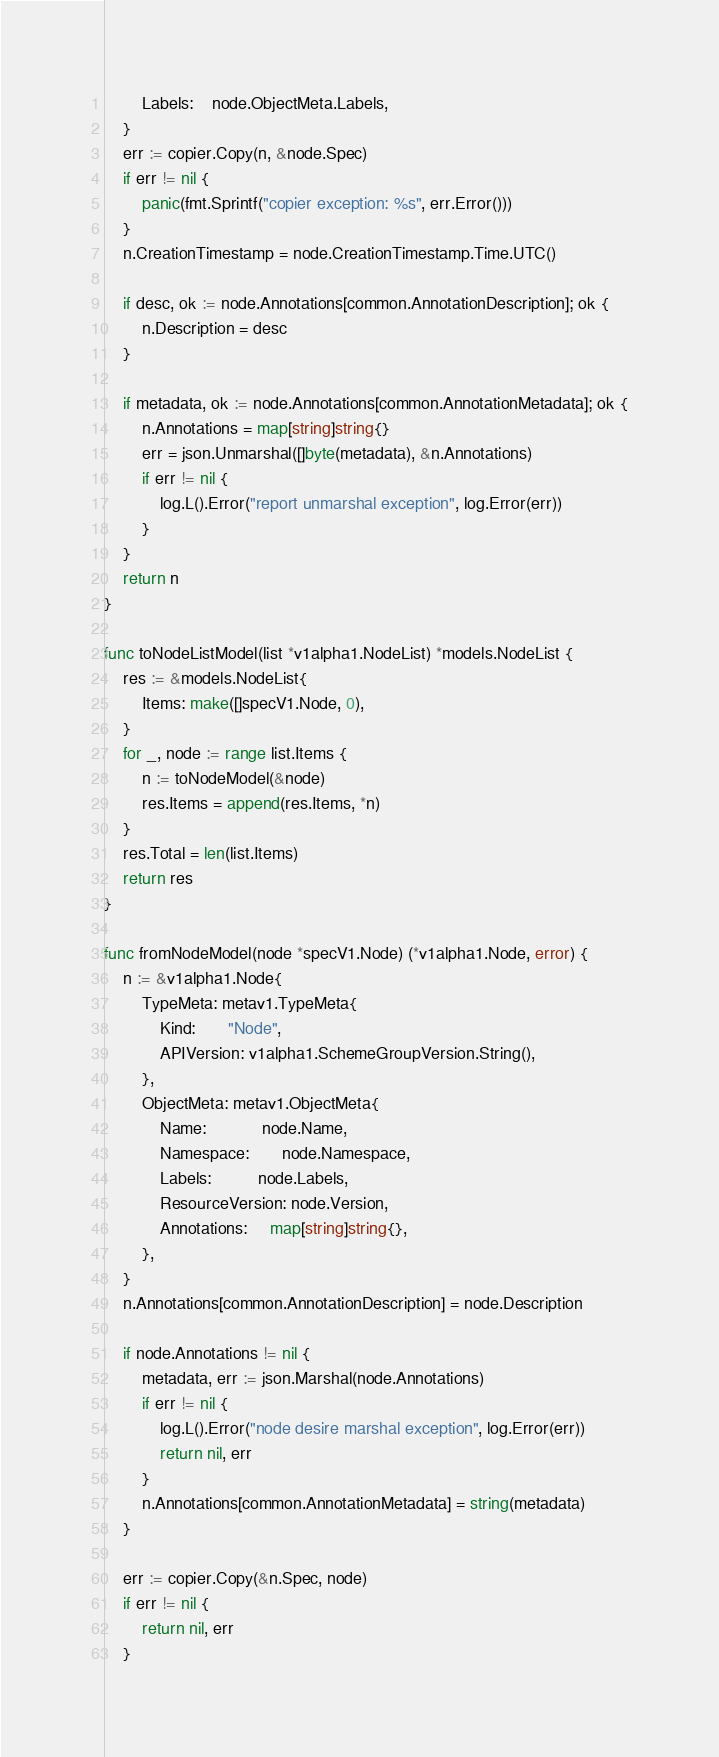Convert code to text. <code><loc_0><loc_0><loc_500><loc_500><_Go_>		Labels:    node.ObjectMeta.Labels,
	}
	err := copier.Copy(n, &node.Spec)
	if err != nil {
		panic(fmt.Sprintf("copier exception: %s", err.Error()))
	}
	n.CreationTimestamp = node.CreationTimestamp.Time.UTC()

	if desc, ok := node.Annotations[common.AnnotationDescription]; ok {
		n.Description = desc
	}

	if metadata, ok := node.Annotations[common.AnnotationMetadata]; ok {
		n.Annotations = map[string]string{}
		err = json.Unmarshal([]byte(metadata), &n.Annotations)
		if err != nil {
			log.L().Error("report unmarshal exception", log.Error(err))
		}
	}
	return n
}

func toNodeListModel(list *v1alpha1.NodeList) *models.NodeList {
	res := &models.NodeList{
		Items: make([]specV1.Node, 0),
	}
	for _, node := range list.Items {
		n := toNodeModel(&node)
		res.Items = append(res.Items, *n)
	}
	res.Total = len(list.Items)
	return res
}

func fromNodeModel(node *specV1.Node) (*v1alpha1.Node, error) {
	n := &v1alpha1.Node{
		TypeMeta: metav1.TypeMeta{
			Kind:       "Node",
			APIVersion: v1alpha1.SchemeGroupVersion.String(),
		},
		ObjectMeta: metav1.ObjectMeta{
			Name:            node.Name,
			Namespace:       node.Namespace,
			Labels:          node.Labels,
			ResourceVersion: node.Version,
			Annotations:     map[string]string{},
		},
	}
	n.Annotations[common.AnnotationDescription] = node.Description

	if node.Annotations != nil {
		metadata, err := json.Marshal(node.Annotations)
		if err != nil {
			log.L().Error("node desire marshal exception", log.Error(err))
			return nil, err
		}
		n.Annotations[common.AnnotationMetadata] = string(metadata)
	}

	err := copier.Copy(&n.Spec, node)
	if err != nil {
		return nil, err
	}
</code> 